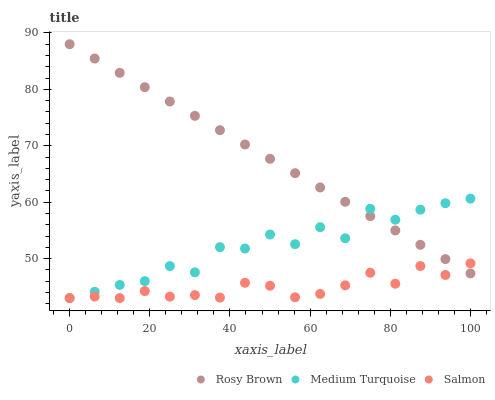Does Salmon have the minimum area under the curve?
Answer yes or no. Yes. Does Rosy Brown have the maximum area under the curve?
Answer yes or no. Yes. Does Medium Turquoise have the minimum area under the curve?
Answer yes or no. No. Does Medium Turquoise have the maximum area under the curve?
Answer yes or no. No. Is Rosy Brown the smoothest?
Answer yes or no. Yes. Is Medium Turquoise the roughest?
Answer yes or no. Yes. Is Salmon the smoothest?
Answer yes or no. No. Is Salmon the roughest?
Answer yes or no. No. Does Salmon have the lowest value?
Answer yes or no. Yes. Does Rosy Brown have the highest value?
Answer yes or no. Yes. Does Medium Turquoise have the highest value?
Answer yes or no. No. Does Medium Turquoise intersect Salmon?
Answer yes or no. Yes. Is Medium Turquoise less than Salmon?
Answer yes or no. No. Is Medium Turquoise greater than Salmon?
Answer yes or no. No. 